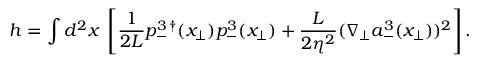Convert formula to latex. <formula><loc_0><loc_0><loc_500><loc_500>h = \int d ^ { 2 } x \, \left [ \frac { 1 } { 2 L } p _ { - } ^ { 3 \, \dagger } ( { x } _ { \bot } ) p _ { - } ^ { 3 } ( { x } _ { \bot } ) + \frac { L } { 2 \eta ^ { 2 } } ( \nabla _ { \bot } a _ { - } ^ { 3 } ( { x } _ { \bot } ) ) ^ { 2 } \right ] .</formula> 